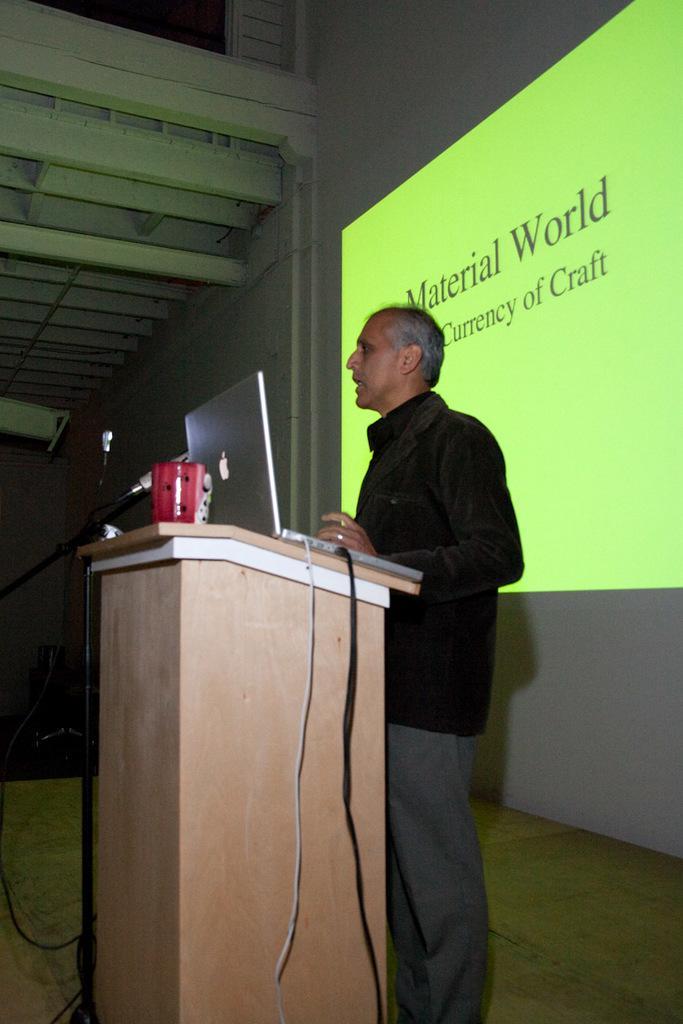How would you summarize this image in a sentence or two? In the center of the image we can see a man standing, before him there is a podium and we can see a laptop and a mug placed on the podium. There is a mic placed on the stand. In the background there is a screen and a wall. 